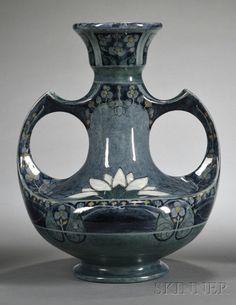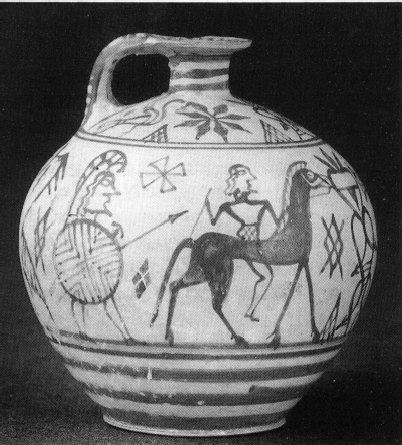The first image is the image on the left, the second image is the image on the right. For the images shown, is this caption "One vessel has at least one handle, is widest around the middle, and features a stylized depiction of a hooved animal in black." true? Answer yes or no. Yes. The first image is the image on the left, the second image is the image on the right. Given the left and right images, does the statement "The vase in the image on the left has two handles." hold true? Answer yes or no. Yes. 